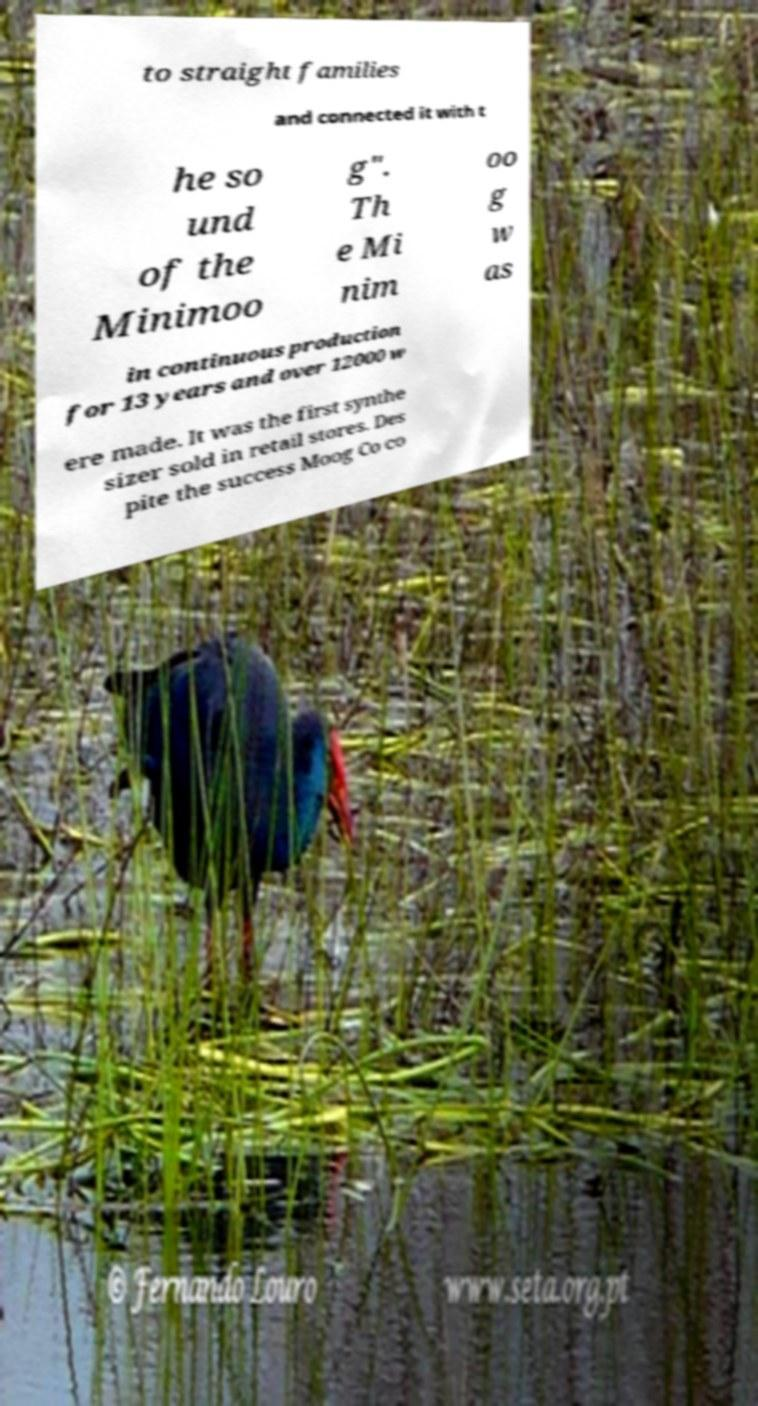Please identify and transcribe the text found in this image. to straight families and connected it with t he so und of the Minimoo g". Th e Mi nim oo g w as in continuous production for 13 years and over 12000 w ere made. It was the first synthe sizer sold in retail stores. Des pite the success Moog Co co 